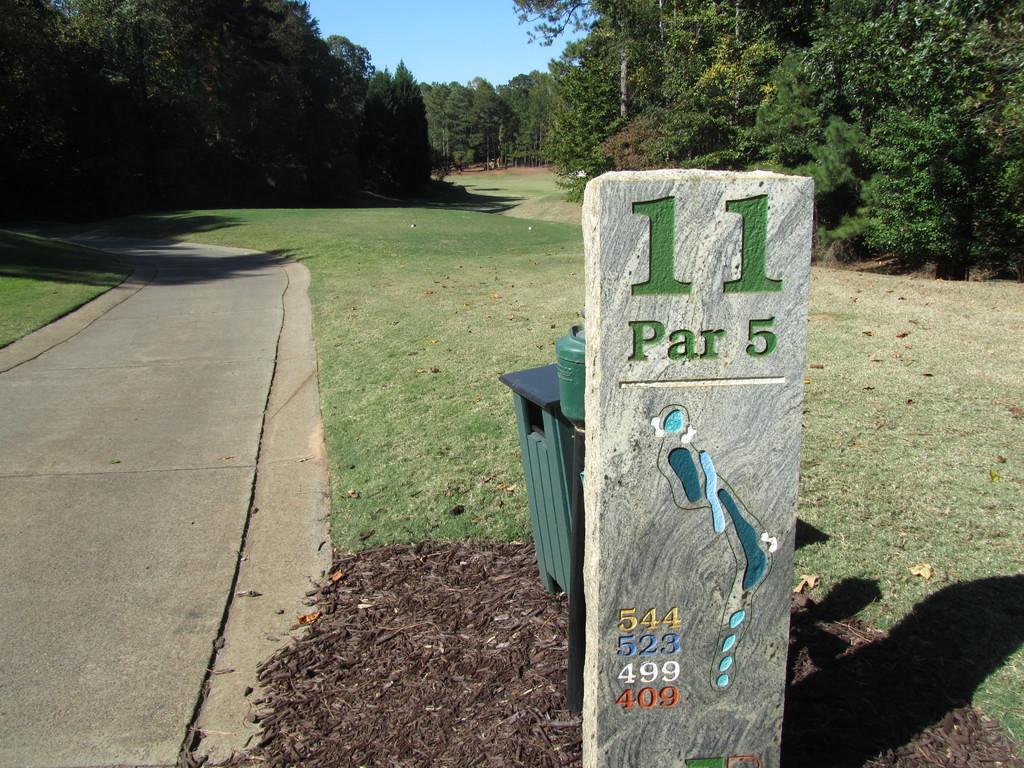What number is written in green?
Give a very brief answer. 11. 